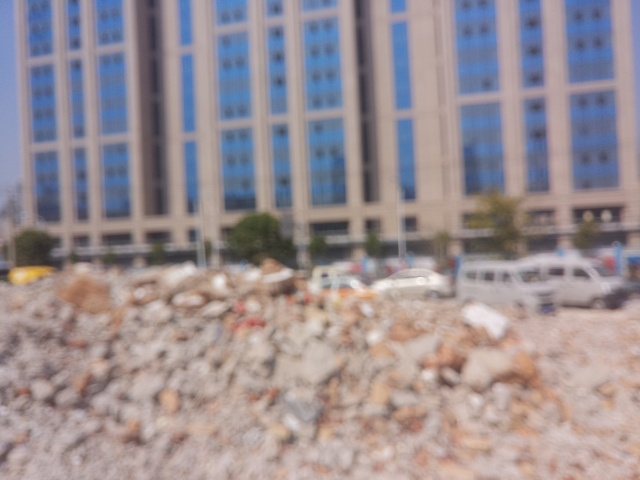Could this image be useful for any purpose given its poor quality? While the poor quality limits its use for detailed analysis, the image could serve as an abstract representation of urban change or the concept of unclear future plans. It can also evoke emotions related to chaos or confusion. 